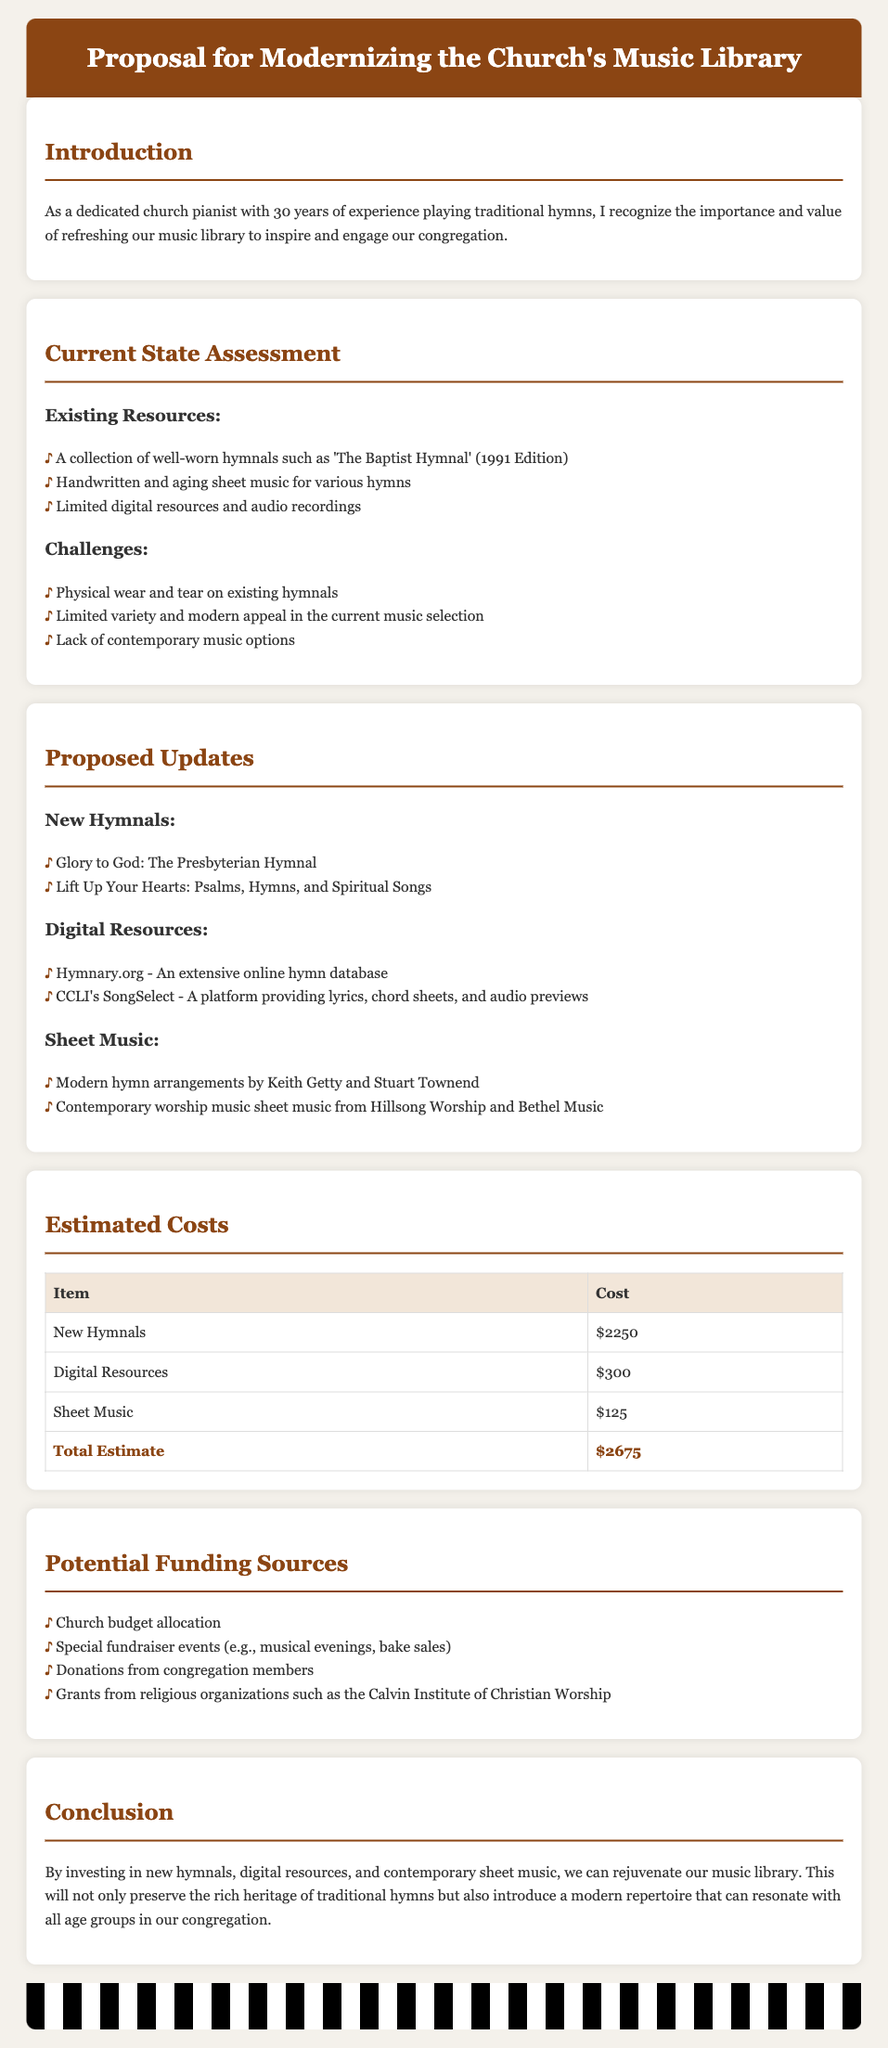What are the new hymnals proposed? The document lists the new hymnals suggested in the proposed updates section.
Answer: Glory to God: The Presbyterian Hymnal, Lift Up Your Hearts: Psalms, Hymns, and Spiritual Songs What is the total estimated cost for the updates? The total estimate is provided in the estimated costs section, summing up all individual costs.
Answer: $2675 Which digital resource provides lyrics, chord sheets, and audio previews? The document specifies a digital resource that offers these features in the proposed updates section.
Answer: CCLI's SongSelect What is one challenge faced by the current music library? The document mentions several challenges in the current state assessment section that highlight issues with existing resources.
Answer: Limited variety and modern appeal in the current music selection What funding sources are mentioned for the modernization proposal? The potential funding sources are listed in a specific section of the document.
Answer: Church budget allocation, Special fundraiser events, Donations from congregation members, Grants from religious organizations What is the main objective of modernizing the church's music library? The conclusion of the document summarizes the primary goal for updating the music library.
Answer: To rejuvenate the music library and resonate with all age groups in the congregation 